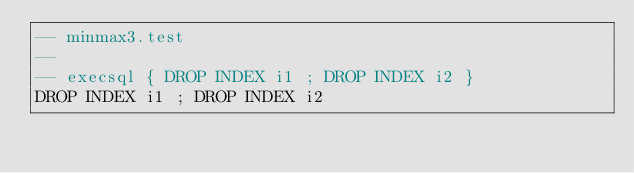Convert code to text. <code><loc_0><loc_0><loc_500><loc_500><_SQL_>-- minmax3.test
-- 
-- execsql { DROP INDEX i1 ; DROP INDEX i2 }
DROP INDEX i1 ; DROP INDEX i2</code> 